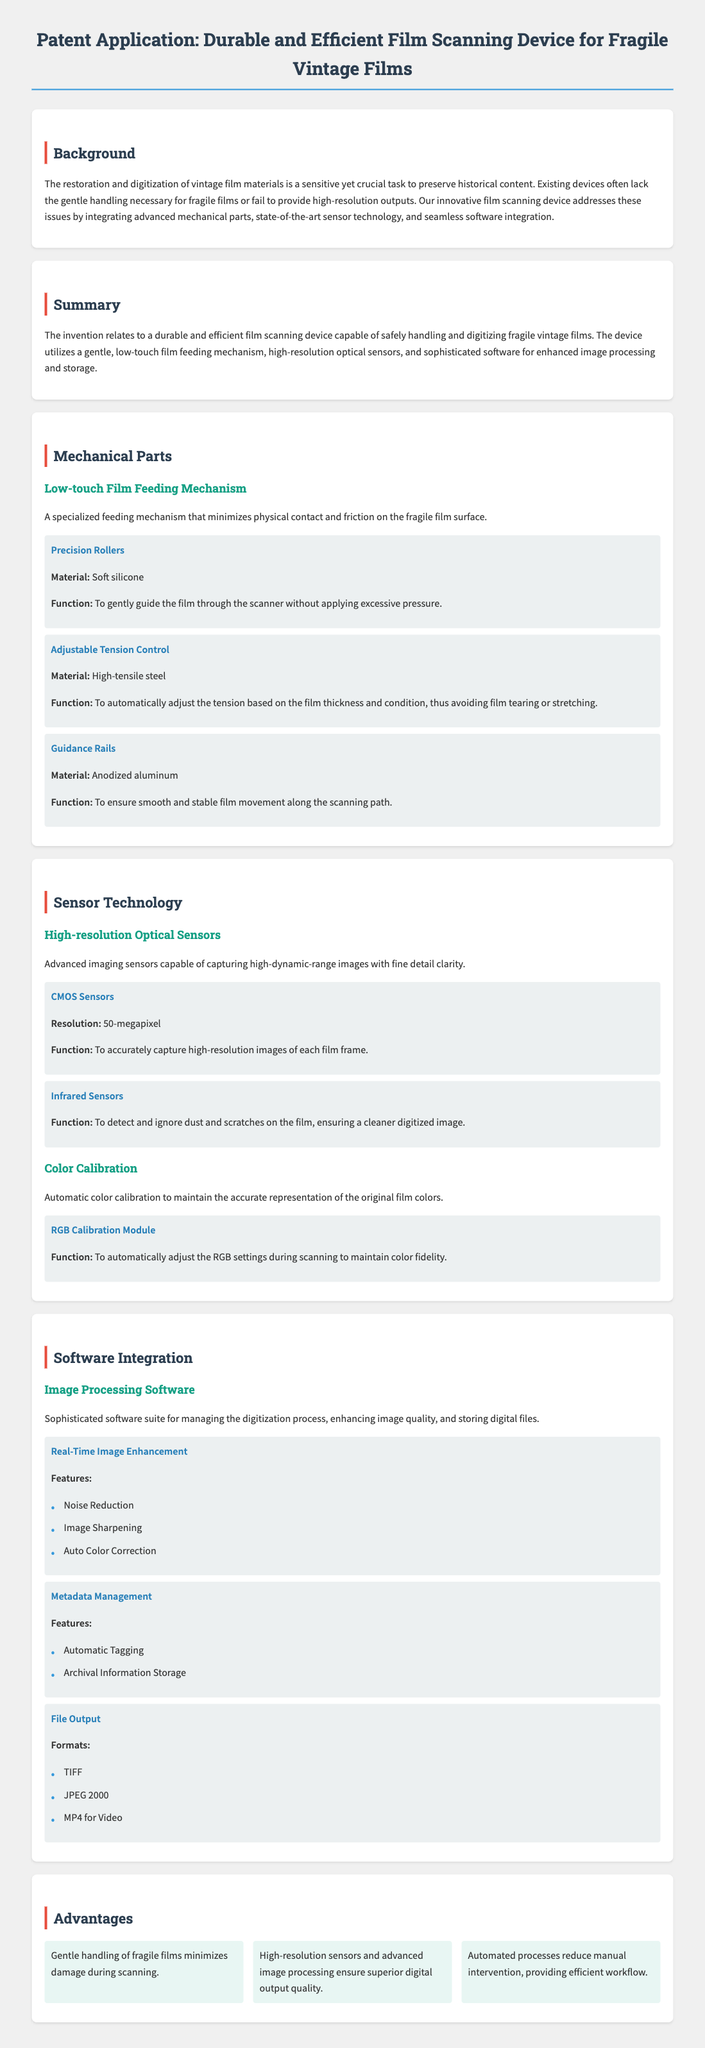What is the primary function of the film scanning device? The primary function is to safely handle and digitize fragile vintage films.
Answer: To safely handle and digitize fragile vintage films What material are the precision rollers made of? The precision rollers are made of soft silicone to gently guide the film.
Answer: Soft silicone How many megapixels do the CMOS sensors have? The resolution of the CMOS sensors is provided in the document, which is 50 megapixels.
Answer: 50-megapixel What does the adjustable tension control do? The adjustable tension control automatically adjusts tension based on film thickness and condition.
Answer: Automatically adjust tension List one feature of the real-time image enhancement software. The document lists features such as noise reduction, image sharpening, and auto color correction. One of the features is noise reduction.
Answer: Noise Reduction What automated feature enhances color fidelity? The RGB Calibration Module is the feature that automatically adjusts RGB settings during scanning.
Answer: RGB Calibration Module What output formats does the device support? The document specifies output formats including TIFF, JPEG 2000, and MP4 for video.
Answer: TIFF, JPEG 2000, MP4 Name one advantage of the film scanning device. One advantage listed in the document is that gentle handling of fragile films minimizes damage during scanning.
Answer: Gentle handling minimizes damage What does metadata management feature include? Features of the metadata management include automatic tagging and archival information storage.
Answer: Automatic tagging, Archival Information Storage 